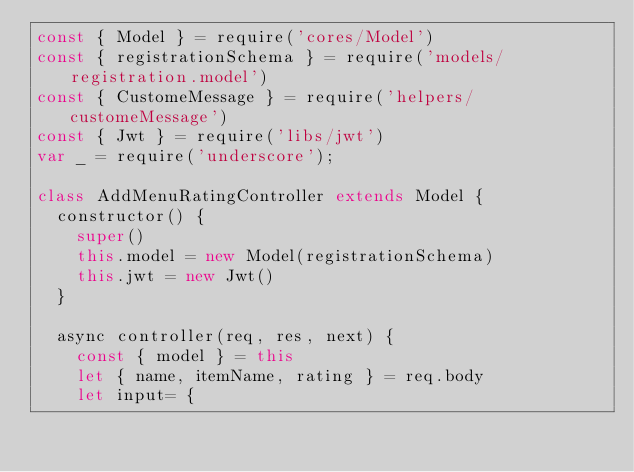<code> <loc_0><loc_0><loc_500><loc_500><_JavaScript_>const { Model } = require('cores/Model')
const { registrationSchema } = require('models/registration.model')
const { CustomeMessage } = require('helpers/customeMessage')
const { Jwt } = require('libs/jwt')
var _ = require('underscore');

class AddMenuRatingController extends Model {
  constructor() {
    super()
    this.model = new Model(registrationSchema)
    this.jwt = new Jwt()
  }

  async controller(req, res, next) {
    const { model } = this
    let { name, itemName, rating } = req.body
    let input= {</code> 